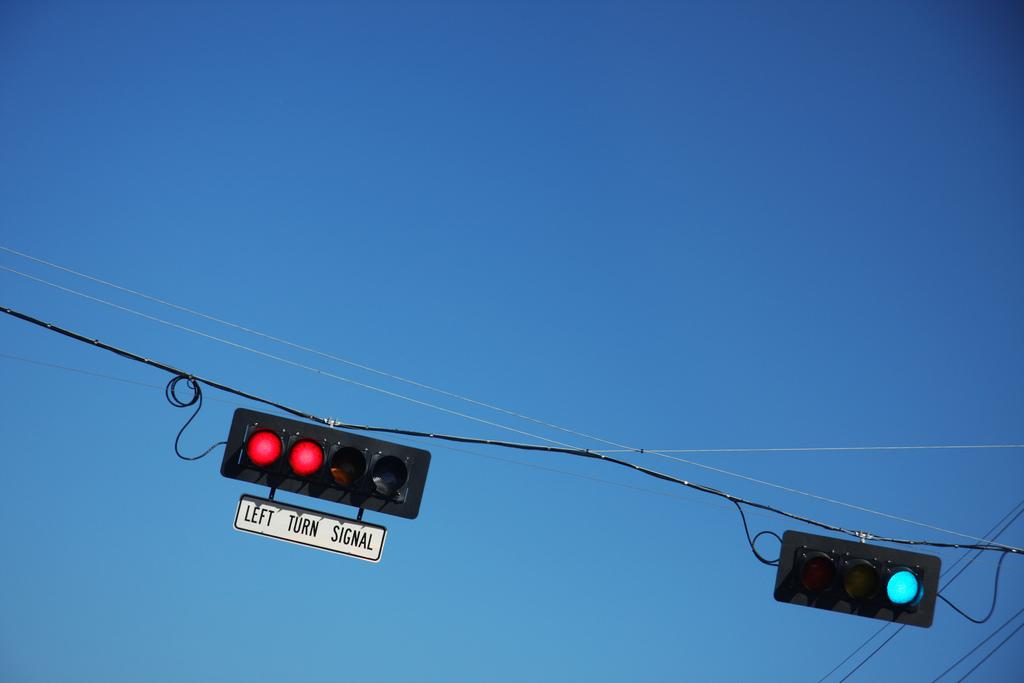What does the red light say underneath it?
Offer a very short reply. Left turn signal. 